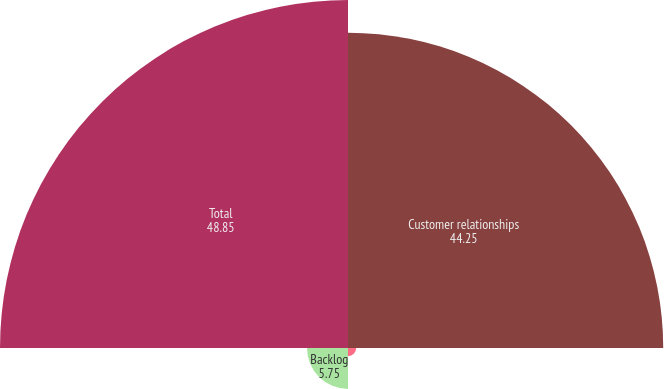Convert chart. <chart><loc_0><loc_0><loc_500><loc_500><pie_chart><fcel>Customer relationships<fcel>Technology-based<fcel>Backlog<fcel>Total<nl><fcel>44.25%<fcel>1.15%<fcel>5.75%<fcel>48.85%<nl></chart> 